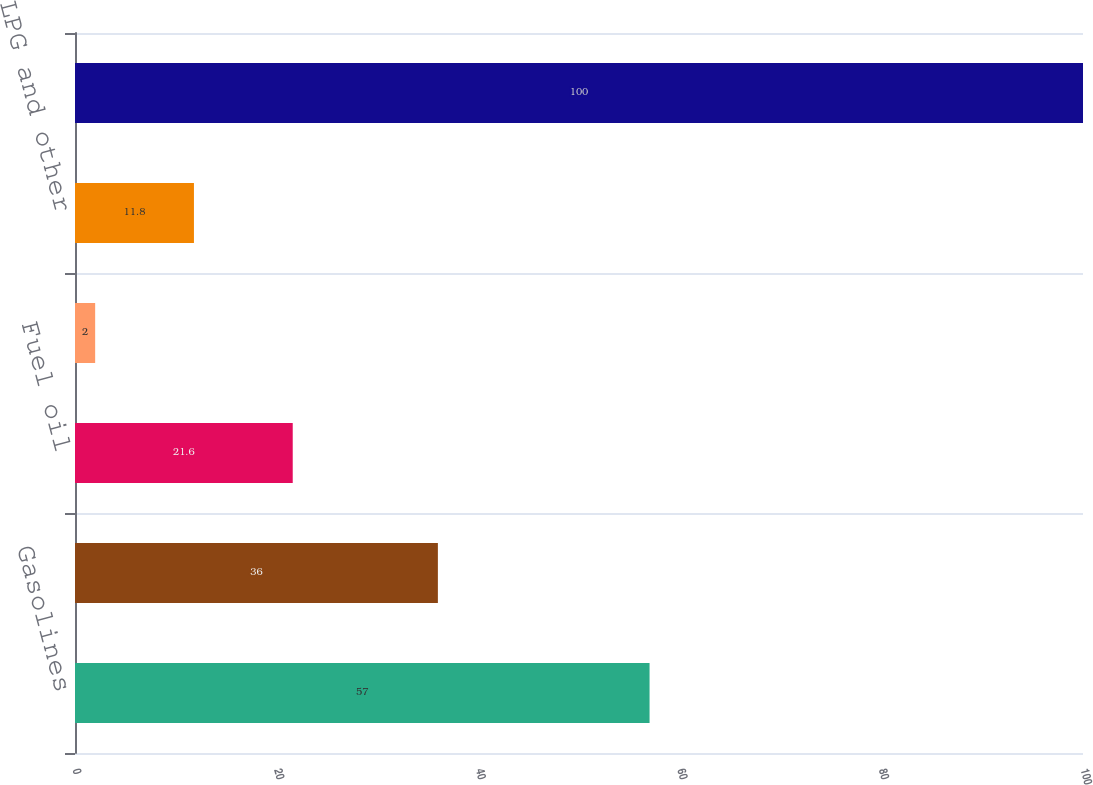Convert chart to OTSL. <chart><loc_0><loc_0><loc_500><loc_500><bar_chart><fcel>Gasolines<fcel>Diesel fuels<fcel>Fuel oil<fcel>Asphalt<fcel>LPG and other<fcel>Total<nl><fcel>57<fcel>36<fcel>21.6<fcel>2<fcel>11.8<fcel>100<nl></chart> 